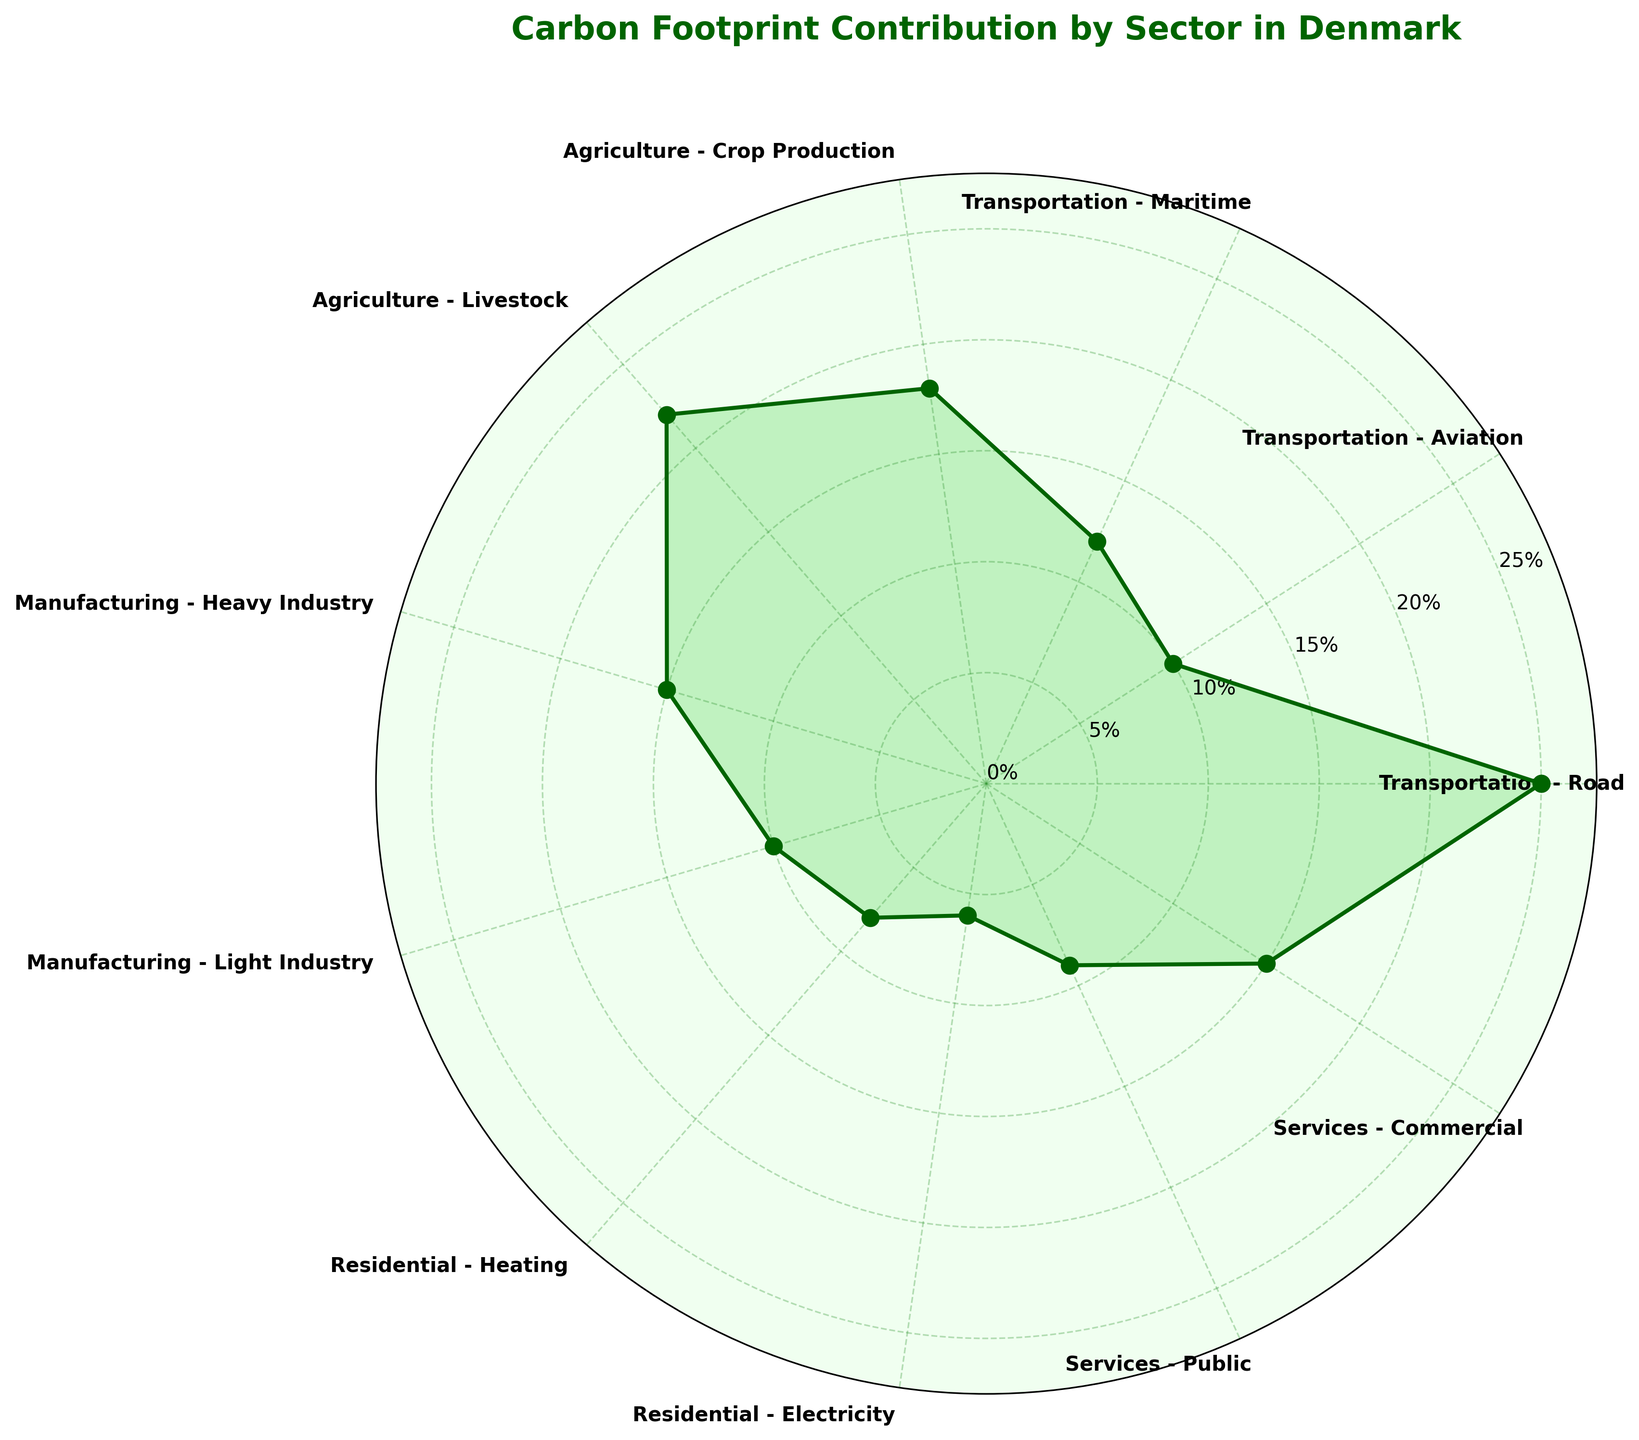What's the title of the figure? The title is located at the top center of the figure and is presented in bold font.
Answer: Carbon Footprint Contribution by Sector in Denmark Which sector has the highest carbon footprint percentage? The sector with the longest radial line and thus the largest colored area is the one with the highest percentage.
Answer: Transportation - Road What is the combined carbon footprint percentage of all transportation sectors? Add the carbon footprint percentages of Transportation - Road (25%), Transportation - Aviation (10%), and Transportation - Maritime (12%). 25 + 10 + 12 = 47
Answer: 47% Which sector within the residential category has a higher carbon footprint percentage? Compare the radial lines of Residential - Heating and Residential - Electricity to determine which one is longer.
Answer: Residential - Heating Among Agriculture - Crop Production and Services - Public, which sector has a lower carbon footprint percentage? Compare the radial lines of Agriculture - Crop Production and Services - Public to see which one is shorter.
Answer: Services - Public What is the difference in carbon footprint percentage between Manufacturing - Heavy Industry and Manufacturing - Light Industry? Subtract the carbon footprint percentage of Manufacturing - Light Industry (10%) from Manufacturing - Heavy Industry (15%). 15 - 10 = 5
Answer: 5% List all sectors with a carbon footprint percentage greater than 15%. Identify sectors with radial lengths representing percentages greater than 15%, which are Transportation - Road (25%), Agriculture - Livestock (22%), and Manufacturing - Heavy Industry (15%) is exactly 15%.
Answer: Transportation - Road, Agriculture - Livestock How many sectors are represented in the figure? Count the number of sectors listed around the polar area chart.
Answer: 11 Which sector has the smallest carbon footprint percentage? Identify the sector with the shortest radial line.
Answer: Residential - Electricity Does Agriculture - Livestock have a higher carbon footprint percentage than any sector in the Services category? Compare the radial line of Agriculture - Livestock with those of Services - Public and Services - Commercial.
Answer: Yes 